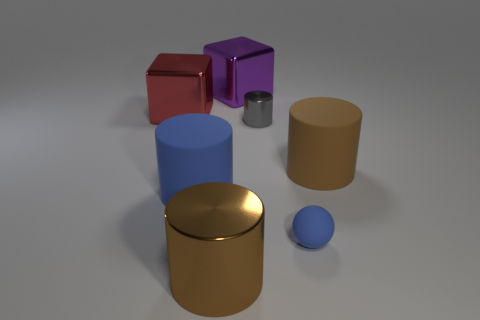Is there anything else that has the same shape as the small blue object?
Give a very brief answer. No. There is a rubber thing on the left side of the small gray cylinder that is behind the large rubber object that is behind the large blue rubber cylinder; what is its shape?
Offer a very short reply. Cylinder. There is a large cylinder that is behind the rubber ball and to the left of the tiny blue matte sphere; what is it made of?
Give a very brief answer. Rubber. What number of other metallic cylinders have the same size as the gray cylinder?
Offer a very short reply. 0. How many rubber objects are either small blue spheres or big purple blocks?
Keep it short and to the point. 1. What material is the blue cylinder?
Offer a very short reply. Rubber. How many shiny things are on the left side of the red metal cube?
Your answer should be very brief. 0. Is the material of the tiny thing that is in front of the small cylinder the same as the red block?
Your answer should be very brief. No. What number of large brown shiny objects have the same shape as the large blue thing?
Provide a succinct answer. 1. What number of big things are either yellow rubber cylinders or brown things?
Make the answer very short. 2. 